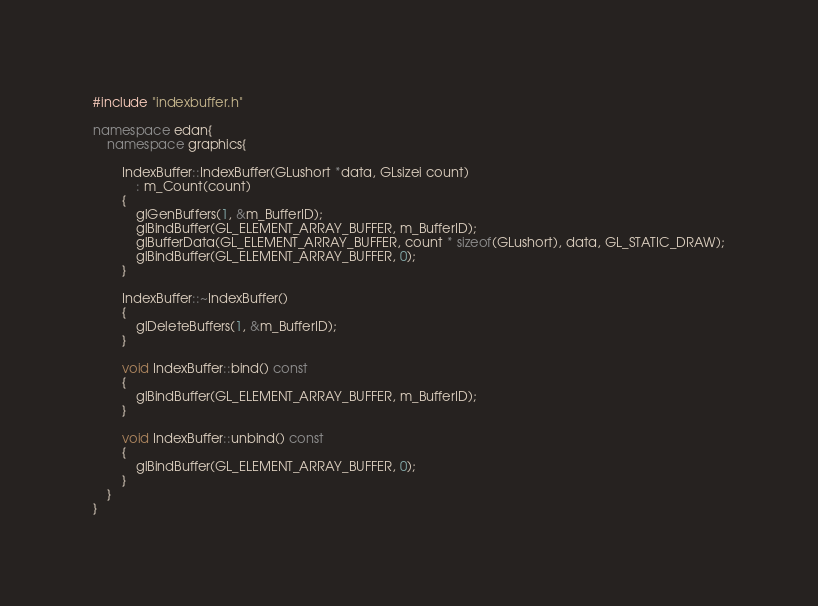<code> <loc_0><loc_0><loc_500><loc_500><_C++_>#include "indexbuffer.h"

namespace edan{
	namespace graphics{

		IndexBuffer::IndexBuffer(GLushort *data, GLsizei count)
			: m_Count(count)
		{
			glGenBuffers(1, &m_BufferID);
			glBindBuffer(GL_ELEMENT_ARRAY_BUFFER, m_BufferID);
			glBufferData(GL_ELEMENT_ARRAY_BUFFER, count * sizeof(GLushort), data, GL_STATIC_DRAW);
			glBindBuffer(GL_ELEMENT_ARRAY_BUFFER, 0);
		}
		
		IndexBuffer::~IndexBuffer()
		{
			glDeleteBuffers(1, &m_BufferID);
		}

		void IndexBuffer::bind() const
		{
			glBindBuffer(GL_ELEMENT_ARRAY_BUFFER, m_BufferID);
		}

		void IndexBuffer::unbind() const
		{
			glBindBuffer(GL_ELEMENT_ARRAY_BUFFER, 0);
		}
	}
}</code> 